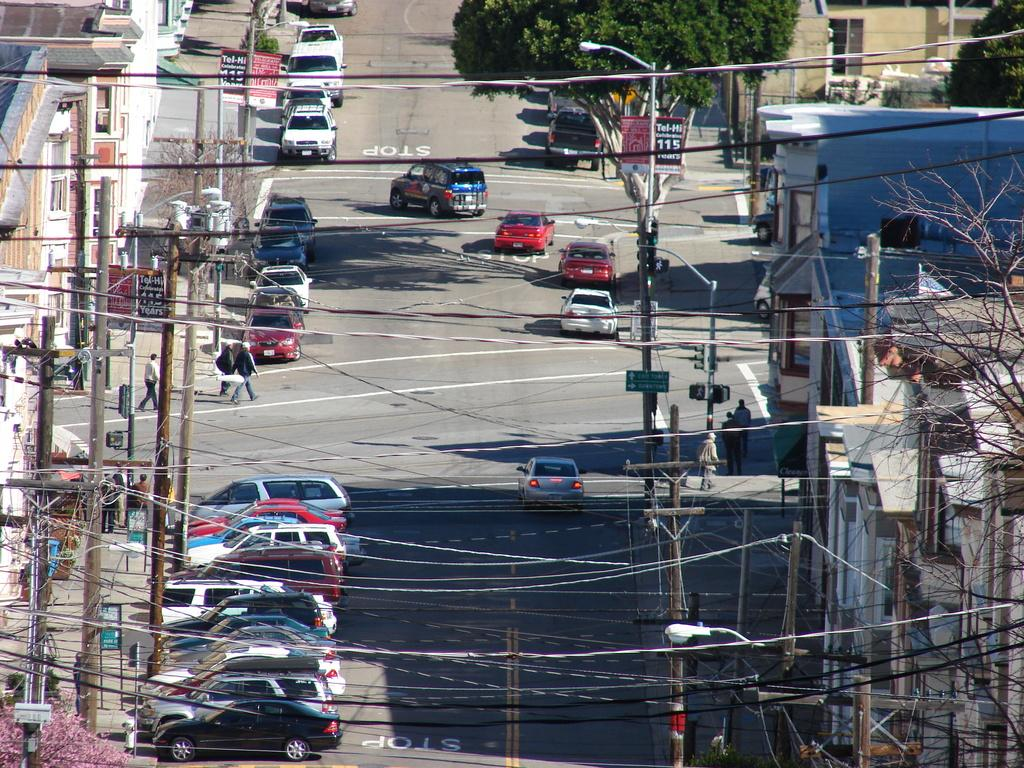What can be seen on the road in the image? There are vehicles and people on the road in the image. What is visible in the background of the image? There are trees, buildings, poles with wires, name boards, and sign boards in the background of the image. How many times does the person on the road fold their arms in the image? There is no information about the person folding their arms in the image. Does the coughing sound come from any person in the image? There is no mention of a coughing sound or any person coughing in the image. 